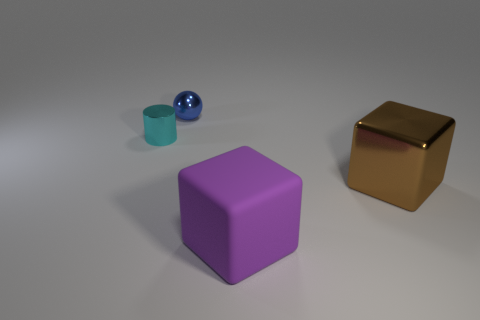There is a big cube behind the purple object; what color is it?
Provide a succinct answer. Brown. There is a small metallic thing that is on the right side of the metallic object that is left of the blue metallic object; what shape is it?
Give a very brief answer. Sphere. How many cylinders are either tiny cyan things or brown metal objects?
Offer a terse response. 1. The object that is both to the right of the tiny cyan shiny cylinder and to the left of the big purple matte cube is made of what material?
Your answer should be compact. Metal. There is a small blue sphere; what number of tiny cylinders are behind it?
Offer a terse response. 0. Do the thing that is on the left side of the small blue shiny thing and the cube in front of the big brown metal cube have the same material?
Your answer should be compact. No. What number of objects are either cyan shiny cylinders that are behind the big rubber thing or small blue things?
Your answer should be very brief. 2. Are there fewer metal things to the right of the small sphere than cubes on the right side of the small cyan metal cylinder?
Give a very brief answer. Yes. What number of other things are there of the same size as the purple rubber block?
Offer a terse response. 1. Does the blue thing have the same material as the block that is behind the purple rubber object?
Offer a very short reply. Yes. 